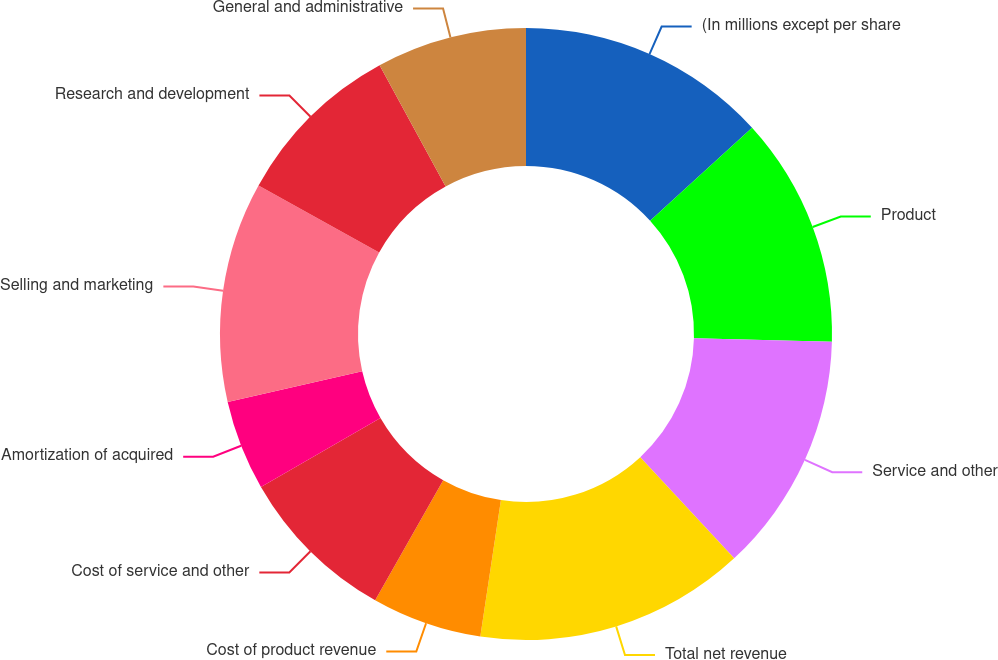Convert chart. <chart><loc_0><loc_0><loc_500><loc_500><pie_chart><fcel>(In millions except per share<fcel>Product<fcel>Service and other<fcel>Total net revenue<fcel>Cost of product revenue<fcel>Cost of service and other<fcel>Amortization of acquired<fcel>Selling and marketing<fcel>Research and development<fcel>General and administrative<nl><fcel>13.23%<fcel>12.17%<fcel>12.7%<fcel>14.29%<fcel>5.82%<fcel>8.47%<fcel>4.76%<fcel>11.64%<fcel>8.99%<fcel>7.94%<nl></chart> 